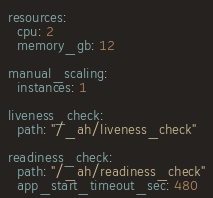Convert code to text. <code><loc_0><loc_0><loc_500><loc_500><_YAML_>resources:
  cpu: 2
  memory_gb: 12

manual_scaling:
  instances: 1

liveness_check:
  path: "/_ah/liveness_check"

readiness_check:
  path: "/_ah/readiness_check"
  app_start_timeout_sec: 480
</code> 